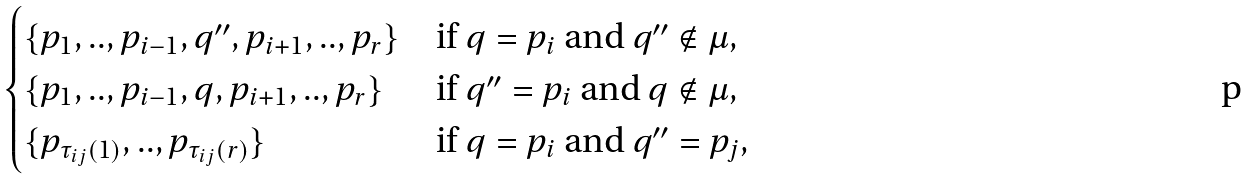<formula> <loc_0><loc_0><loc_500><loc_500>\begin{cases} \{ p _ { 1 } , . . , p _ { i - 1 } , q ^ { \prime \prime } , p _ { i + 1 } , . . , p _ { r } \} & \text {if $q=p_{i}$ and $q^{\prime\prime}\notin\mu$} , \\ \{ p _ { 1 } , . . , p _ { i - 1 } , q , p _ { i + 1 } , . . , p _ { r } \} & \text {if $q^{\prime\prime}=p_{i}$ and $q\notin\mu$} , \\ \{ p _ { \tau _ { i j } ( 1 ) } , . . , p _ { \tau _ { i j } ( r ) } \} & \text {if $q=p_{i}$ and $q^{\prime\prime}=p_{j}$} , \\ \end{cases}</formula> 